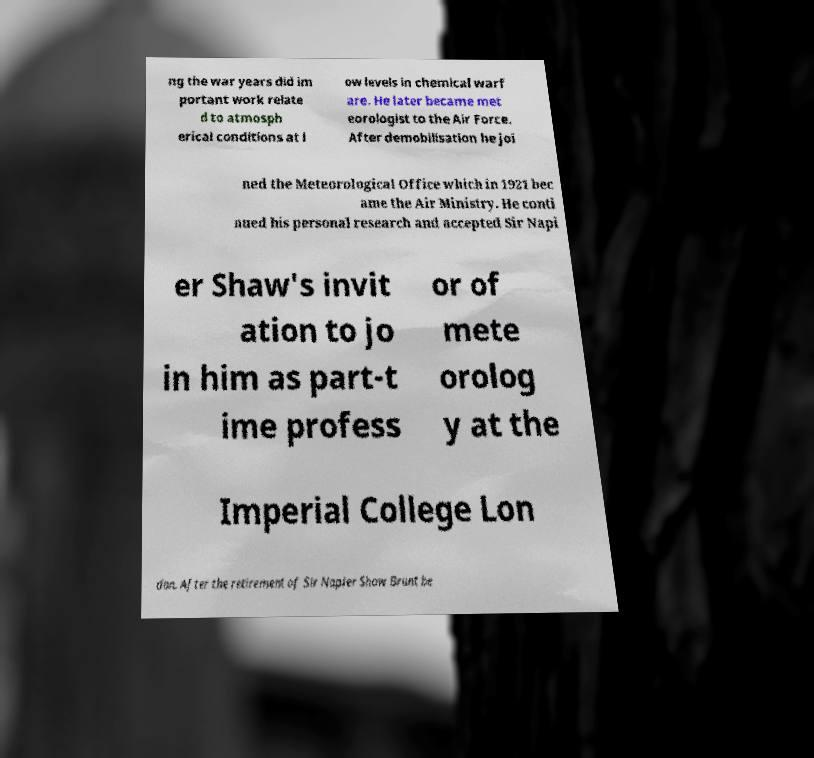Please read and relay the text visible in this image. What does it say? ng the war years did im portant work relate d to atmosph erical conditions at l ow levels in chemical warf are. He later became met eorologist to the Air Force. After demobilisation he joi ned the Meteorological Office which in 1921 bec ame the Air Ministry. He conti nued his personal research and accepted Sir Napi er Shaw's invit ation to jo in him as part-t ime profess or of mete orolog y at the Imperial College Lon don. After the retirement of Sir Napier Shaw Brunt be 